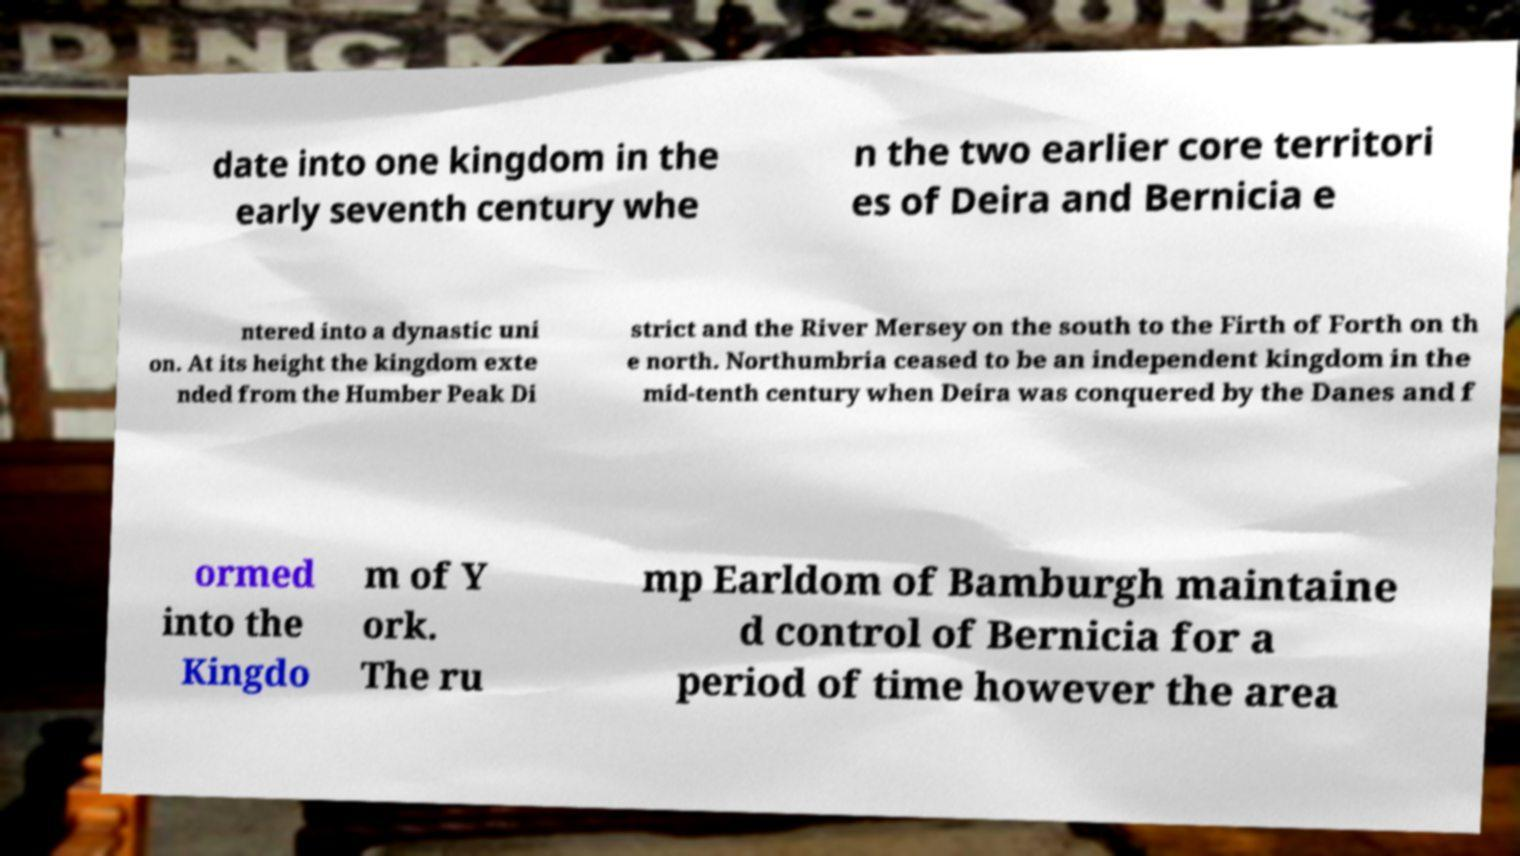Can you accurately transcribe the text from the provided image for me? date into one kingdom in the early seventh century whe n the two earlier core territori es of Deira and Bernicia e ntered into a dynastic uni on. At its height the kingdom exte nded from the Humber Peak Di strict and the River Mersey on the south to the Firth of Forth on th e north. Northumbria ceased to be an independent kingdom in the mid-tenth century when Deira was conquered by the Danes and f ormed into the Kingdo m of Y ork. The ru mp Earldom of Bamburgh maintaine d control of Bernicia for a period of time however the area 